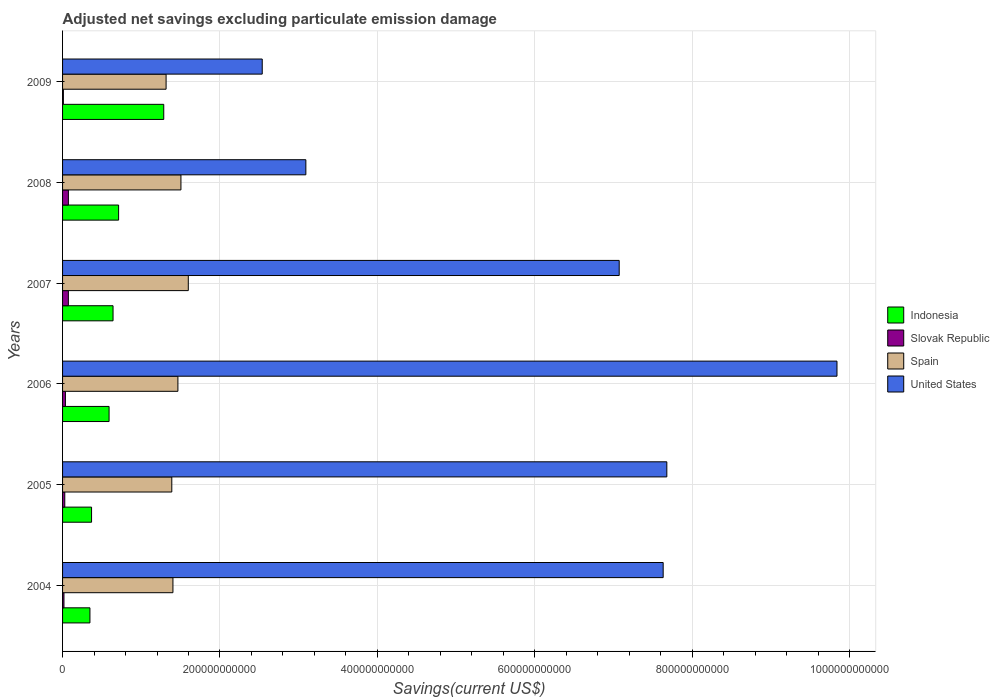Are the number of bars per tick equal to the number of legend labels?
Ensure brevity in your answer.  Yes. Are the number of bars on each tick of the Y-axis equal?
Your response must be concise. Yes. How many bars are there on the 4th tick from the top?
Keep it short and to the point. 4. How many bars are there on the 4th tick from the bottom?
Your response must be concise. 4. What is the label of the 3rd group of bars from the top?
Make the answer very short. 2007. What is the adjusted net savings in Spain in 2006?
Provide a short and direct response. 1.47e+11. Across all years, what is the maximum adjusted net savings in Slovak Republic?
Your answer should be compact. 7.40e+09. Across all years, what is the minimum adjusted net savings in Spain?
Your answer should be very brief. 1.32e+11. In which year was the adjusted net savings in United States maximum?
Your answer should be very brief. 2006. What is the total adjusted net savings in Spain in the graph?
Provide a short and direct response. 8.67e+11. What is the difference between the adjusted net savings in United States in 2005 and that in 2007?
Offer a terse response. 6.05e+1. What is the difference between the adjusted net savings in United States in 2004 and the adjusted net savings in Spain in 2008?
Provide a short and direct response. 6.13e+11. What is the average adjusted net savings in Indonesia per year?
Offer a very short reply. 6.58e+1. In the year 2007, what is the difference between the adjusted net savings in Spain and adjusted net savings in Indonesia?
Provide a short and direct response. 9.56e+1. In how many years, is the adjusted net savings in Indonesia greater than 720000000000 US$?
Your answer should be very brief. 0. What is the ratio of the adjusted net savings in United States in 2006 to that in 2007?
Ensure brevity in your answer.  1.39. Is the adjusted net savings in Slovak Republic in 2004 less than that in 2009?
Offer a very short reply. No. Is the difference between the adjusted net savings in Spain in 2004 and 2005 greater than the difference between the adjusted net savings in Indonesia in 2004 and 2005?
Offer a very short reply. Yes. What is the difference between the highest and the second highest adjusted net savings in Slovak Republic?
Your answer should be compact. 1.79e+07. What is the difference between the highest and the lowest adjusted net savings in Slovak Republic?
Your answer should be compact. 6.35e+09. In how many years, is the adjusted net savings in Indonesia greater than the average adjusted net savings in Indonesia taken over all years?
Your answer should be compact. 2. What does the 4th bar from the top in 2008 represents?
Your response must be concise. Indonesia. What does the 4th bar from the bottom in 2008 represents?
Make the answer very short. United States. Is it the case that in every year, the sum of the adjusted net savings in Slovak Republic and adjusted net savings in United States is greater than the adjusted net savings in Indonesia?
Provide a short and direct response. Yes. Are all the bars in the graph horizontal?
Make the answer very short. Yes. What is the difference between two consecutive major ticks on the X-axis?
Give a very brief answer. 2.00e+11. Are the values on the major ticks of X-axis written in scientific E-notation?
Ensure brevity in your answer.  No. Does the graph contain grids?
Ensure brevity in your answer.  Yes. How are the legend labels stacked?
Offer a terse response. Vertical. What is the title of the graph?
Offer a terse response. Adjusted net savings excluding particulate emission damage. What is the label or title of the X-axis?
Your answer should be very brief. Savings(current US$). What is the Savings(current US$) in Indonesia in 2004?
Provide a succinct answer. 3.48e+1. What is the Savings(current US$) of Slovak Republic in 2004?
Keep it short and to the point. 1.77e+09. What is the Savings(current US$) of Spain in 2004?
Make the answer very short. 1.40e+11. What is the Savings(current US$) of United States in 2004?
Your answer should be compact. 7.63e+11. What is the Savings(current US$) of Indonesia in 2005?
Your answer should be compact. 3.68e+1. What is the Savings(current US$) in Slovak Republic in 2005?
Offer a terse response. 2.82e+09. What is the Savings(current US$) in Spain in 2005?
Your answer should be very brief. 1.39e+11. What is the Savings(current US$) in United States in 2005?
Offer a very short reply. 7.68e+11. What is the Savings(current US$) of Indonesia in 2006?
Offer a terse response. 5.91e+1. What is the Savings(current US$) in Slovak Republic in 2006?
Offer a very short reply. 3.63e+09. What is the Savings(current US$) of Spain in 2006?
Provide a short and direct response. 1.47e+11. What is the Savings(current US$) of United States in 2006?
Provide a short and direct response. 9.84e+11. What is the Savings(current US$) of Indonesia in 2007?
Offer a very short reply. 6.41e+1. What is the Savings(current US$) in Slovak Republic in 2007?
Your response must be concise. 7.38e+09. What is the Savings(current US$) in Spain in 2007?
Offer a very short reply. 1.60e+11. What is the Savings(current US$) in United States in 2007?
Provide a succinct answer. 7.07e+11. What is the Savings(current US$) in Indonesia in 2008?
Your response must be concise. 7.12e+1. What is the Savings(current US$) in Slovak Republic in 2008?
Keep it short and to the point. 7.40e+09. What is the Savings(current US$) of Spain in 2008?
Your answer should be compact. 1.50e+11. What is the Savings(current US$) in United States in 2008?
Offer a terse response. 3.09e+11. What is the Savings(current US$) of Indonesia in 2009?
Your response must be concise. 1.29e+11. What is the Savings(current US$) of Slovak Republic in 2009?
Keep it short and to the point. 1.05e+09. What is the Savings(current US$) of Spain in 2009?
Provide a succinct answer. 1.32e+11. What is the Savings(current US$) of United States in 2009?
Give a very brief answer. 2.54e+11. Across all years, what is the maximum Savings(current US$) in Indonesia?
Provide a short and direct response. 1.29e+11. Across all years, what is the maximum Savings(current US$) in Slovak Republic?
Keep it short and to the point. 7.40e+09. Across all years, what is the maximum Savings(current US$) in Spain?
Offer a very short reply. 1.60e+11. Across all years, what is the maximum Savings(current US$) of United States?
Ensure brevity in your answer.  9.84e+11. Across all years, what is the minimum Savings(current US$) of Indonesia?
Provide a succinct answer. 3.48e+1. Across all years, what is the minimum Savings(current US$) in Slovak Republic?
Provide a short and direct response. 1.05e+09. Across all years, what is the minimum Savings(current US$) in Spain?
Your answer should be compact. 1.32e+11. Across all years, what is the minimum Savings(current US$) of United States?
Provide a succinct answer. 2.54e+11. What is the total Savings(current US$) of Indonesia in the graph?
Your answer should be compact. 3.95e+11. What is the total Savings(current US$) of Slovak Republic in the graph?
Your response must be concise. 2.41e+1. What is the total Savings(current US$) of Spain in the graph?
Your answer should be very brief. 8.67e+11. What is the total Savings(current US$) in United States in the graph?
Your answer should be very brief. 3.79e+12. What is the difference between the Savings(current US$) in Indonesia in 2004 and that in 2005?
Provide a short and direct response. -2.07e+09. What is the difference between the Savings(current US$) of Slovak Republic in 2004 and that in 2005?
Provide a short and direct response. -1.05e+09. What is the difference between the Savings(current US$) in Spain in 2004 and that in 2005?
Your answer should be very brief. 1.45e+09. What is the difference between the Savings(current US$) of United States in 2004 and that in 2005?
Provide a short and direct response. -4.65e+09. What is the difference between the Savings(current US$) in Indonesia in 2004 and that in 2006?
Provide a short and direct response. -2.43e+1. What is the difference between the Savings(current US$) in Slovak Republic in 2004 and that in 2006?
Provide a short and direct response. -1.85e+09. What is the difference between the Savings(current US$) of Spain in 2004 and that in 2006?
Offer a very short reply. -6.31e+09. What is the difference between the Savings(current US$) in United States in 2004 and that in 2006?
Your response must be concise. -2.21e+11. What is the difference between the Savings(current US$) of Indonesia in 2004 and that in 2007?
Your response must be concise. -2.94e+1. What is the difference between the Savings(current US$) of Slovak Republic in 2004 and that in 2007?
Keep it short and to the point. -5.61e+09. What is the difference between the Savings(current US$) in Spain in 2004 and that in 2007?
Your response must be concise. -1.95e+1. What is the difference between the Savings(current US$) of United States in 2004 and that in 2007?
Your answer should be compact. 5.59e+1. What is the difference between the Savings(current US$) in Indonesia in 2004 and that in 2008?
Your response must be concise. -3.64e+1. What is the difference between the Savings(current US$) in Slovak Republic in 2004 and that in 2008?
Provide a short and direct response. -5.62e+09. What is the difference between the Savings(current US$) in Spain in 2004 and that in 2008?
Provide a succinct answer. -1.02e+1. What is the difference between the Savings(current US$) in United States in 2004 and that in 2008?
Ensure brevity in your answer.  4.54e+11. What is the difference between the Savings(current US$) of Indonesia in 2004 and that in 2009?
Provide a succinct answer. -9.38e+1. What is the difference between the Savings(current US$) in Slovak Republic in 2004 and that in 2009?
Keep it short and to the point. 7.22e+08. What is the difference between the Savings(current US$) of Spain in 2004 and that in 2009?
Make the answer very short. 8.71e+09. What is the difference between the Savings(current US$) of United States in 2004 and that in 2009?
Provide a succinct answer. 5.09e+11. What is the difference between the Savings(current US$) in Indonesia in 2005 and that in 2006?
Keep it short and to the point. -2.22e+1. What is the difference between the Savings(current US$) in Slovak Republic in 2005 and that in 2006?
Offer a very short reply. -8.02e+08. What is the difference between the Savings(current US$) in Spain in 2005 and that in 2006?
Offer a very short reply. -7.76e+09. What is the difference between the Savings(current US$) of United States in 2005 and that in 2006?
Keep it short and to the point. -2.16e+11. What is the difference between the Savings(current US$) of Indonesia in 2005 and that in 2007?
Your answer should be very brief. -2.73e+1. What is the difference between the Savings(current US$) in Slovak Republic in 2005 and that in 2007?
Ensure brevity in your answer.  -4.56e+09. What is the difference between the Savings(current US$) in Spain in 2005 and that in 2007?
Your answer should be compact. -2.10e+1. What is the difference between the Savings(current US$) of United States in 2005 and that in 2007?
Ensure brevity in your answer.  6.05e+1. What is the difference between the Savings(current US$) in Indonesia in 2005 and that in 2008?
Your response must be concise. -3.44e+1. What is the difference between the Savings(current US$) of Slovak Republic in 2005 and that in 2008?
Make the answer very short. -4.57e+09. What is the difference between the Savings(current US$) of Spain in 2005 and that in 2008?
Offer a terse response. -1.16e+1. What is the difference between the Savings(current US$) of United States in 2005 and that in 2008?
Provide a short and direct response. 4.59e+11. What is the difference between the Savings(current US$) of Indonesia in 2005 and that in 2009?
Make the answer very short. -9.17e+1. What is the difference between the Savings(current US$) in Slovak Republic in 2005 and that in 2009?
Offer a terse response. 1.77e+09. What is the difference between the Savings(current US$) in Spain in 2005 and that in 2009?
Your answer should be compact. 7.26e+09. What is the difference between the Savings(current US$) of United States in 2005 and that in 2009?
Ensure brevity in your answer.  5.14e+11. What is the difference between the Savings(current US$) of Indonesia in 2006 and that in 2007?
Your response must be concise. -5.05e+09. What is the difference between the Savings(current US$) of Slovak Republic in 2006 and that in 2007?
Your answer should be compact. -3.75e+09. What is the difference between the Savings(current US$) of Spain in 2006 and that in 2007?
Make the answer very short. -1.32e+1. What is the difference between the Savings(current US$) of United States in 2006 and that in 2007?
Ensure brevity in your answer.  2.77e+11. What is the difference between the Savings(current US$) of Indonesia in 2006 and that in 2008?
Offer a terse response. -1.21e+1. What is the difference between the Savings(current US$) of Slovak Republic in 2006 and that in 2008?
Offer a very short reply. -3.77e+09. What is the difference between the Savings(current US$) of Spain in 2006 and that in 2008?
Keep it short and to the point. -3.86e+09. What is the difference between the Savings(current US$) in United States in 2006 and that in 2008?
Your response must be concise. 6.75e+11. What is the difference between the Savings(current US$) in Indonesia in 2006 and that in 2009?
Give a very brief answer. -6.95e+1. What is the difference between the Savings(current US$) of Slovak Republic in 2006 and that in 2009?
Ensure brevity in your answer.  2.57e+09. What is the difference between the Savings(current US$) of Spain in 2006 and that in 2009?
Offer a very short reply. 1.50e+1. What is the difference between the Savings(current US$) of United States in 2006 and that in 2009?
Make the answer very short. 7.30e+11. What is the difference between the Savings(current US$) in Indonesia in 2007 and that in 2008?
Keep it short and to the point. -7.06e+09. What is the difference between the Savings(current US$) in Slovak Republic in 2007 and that in 2008?
Offer a terse response. -1.79e+07. What is the difference between the Savings(current US$) in Spain in 2007 and that in 2008?
Offer a very short reply. 9.34e+09. What is the difference between the Savings(current US$) of United States in 2007 and that in 2008?
Provide a short and direct response. 3.98e+11. What is the difference between the Savings(current US$) of Indonesia in 2007 and that in 2009?
Offer a very short reply. -6.44e+1. What is the difference between the Savings(current US$) in Slovak Republic in 2007 and that in 2009?
Your answer should be compact. 6.33e+09. What is the difference between the Savings(current US$) in Spain in 2007 and that in 2009?
Your answer should be compact. 2.82e+1. What is the difference between the Savings(current US$) of United States in 2007 and that in 2009?
Offer a very short reply. 4.54e+11. What is the difference between the Savings(current US$) of Indonesia in 2008 and that in 2009?
Provide a succinct answer. -5.74e+1. What is the difference between the Savings(current US$) of Slovak Republic in 2008 and that in 2009?
Provide a succinct answer. 6.35e+09. What is the difference between the Savings(current US$) of Spain in 2008 and that in 2009?
Your answer should be very brief. 1.89e+1. What is the difference between the Savings(current US$) of United States in 2008 and that in 2009?
Offer a very short reply. 5.54e+1. What is the difference between the Savings(current US$) of Indonesia in 2004 and the Savings(current US$) of Slovak Republic in 2005?
Offer a terse response. 3.19e+1. What is the difference between the Savings(current US$) of Indonesia in 2004 and the Savings(current US$) of Spain in 2005?
Your response must be concise. -1.04e+11. What is the difference between the Savings(current US$) of Indonesia in 2004 and the Savings(current US$) of United States in 2005?
Offer a terse response. -7.33e+11. What is the difference between the Savings(current US$) in Slovak Republic in 2004 and the Savings(current US$) in Spain in 2005?
Ensure brevity in your answer.  -1.37e+11. What is the difference between the Savings(current US$) in Slovak Republic in 2004 and the Savings(current US$) in United States in 2005?
Your response must be concise. -7.66e+11. What is the difference between the Savings(current US$) of Spain in 2004 and the Savings(current US$) of United States in 2005?
Your answer should be very brief. -6.28e+11. What is the difference between the Savings(current US$) in Indonesia in 2004 and the Savings(current US$) in Slovak Republic in 2006?
Your response must be concise. 3.11e+1. What is the difference between the Savings(current US$) of Indonesia in 2004 and the Savings(current US$) of Spain in 2006?
Provide a succinct answer. -1.12e+11. What is the difference between the Savings(current US$) in Indonesia in 2004 and the Savings(current US$) in United States in 2006?
Your answer should be very brief. -9.49e+11. What is the difference between the Savings(current US$) in Slovak Republic in 2004 and the Savings(current US$) in Spain in 2006?
Ensure brevity in your answer.  -1.45e+11. What is the difference between the Savings(current US$) of Slovak Republic in 2004 and the Savings(current US$) of United States in 2006?
Offer a very short reply. -9.82e+11. What is the difference between the Savings(current US$) of Spain in 2004 and the Savings(current US$) of United States in 2006?
Offer a very short reply. -8.44e+11. What is the difference between the Savings(current US$) in Indonesia in 2004 and the Savings(current US$) in Slovak Republic in 2007?
Make the answer very short. 2.74e+1. What is the difference between the Savings(current US$) of Indonesia in 2004 and the Savings(current US$) of Spain in 2007?
Provide a short and direct response. -1.25e+11. What is the difference between the Savings(current US$) in Indonesia in 2004 and the Savings(current US$) in United States in 2007?
Your answer should be compact. -6.73e+11. What is the difference between the Savings(current US$) of Slovak Republic in 2004 and the Savings(current US$) of Spain in 2007?
Make the answer very short. -1.58e+11. What is the difference between the Savings(current US$) of Slovak Republic in 2004 and the Savings(current US$) of United States in 2007?
Provide a short and direct response. -7.06e+11. What is the difference between the Savings(current US$) in Spain in 2004 and the Savings(current US$) in United States in 2007?
Ensure brevity in your answer.  -5.67e+11. What is the difference between the Savings(current US$) in Indonesia in 2004 and the Savings(current US$) in Slovak Republic in 2008?
Your answer should be compact. 2.74e+1. What is the difference between the Savings(current US$) in Indonesia in 2004 and the Savings(current US$) in Spain in 2008?
Ensure brevity in your answer.  -1.16e+11. What is the difference between the Savings(current US$) in Indonesia in 2004 and the Savings(current US$) in United States in 2008?
Your response must be concise. -2.74e+11. What is the difference between the Savings(current US$) of Slovak Republic in 2004 and the Savings(current US$) of Spain in 2008?
Provide a short and direct response. -1.49e+11. What is the difference between the Savings(current US$) in Slovak Republic in 2004 and the Savings(current US$) in United States in 2008?
Offer a very short reply. -3.07e+11. What is the difference between the Savings(current US$) in Spain in 2004 and the Savings(current US$) in United States in 2008?
Provide a short and direct response. -1.69e+11. What is the difference between the Savings(current US$) in Indonesia in 2004 and the Savings(current US$) in Slovak Republic in 2009?
Offer a very short reply. 3.37e+1. What is the difference between the Savings(current US$) of Indonesia in 2004 and the Savings(current US$) of Spain in 2009?
Keep it short and to the point. -9.68e+1. What is the difference between the Savings(current US$) in Indonesia in 2004 and the Savings(current US$) in United States in 2009?
Provide a short and direct response. -2.19e+11. What is the difference between the Savings(current US$) in Slovak Republic in 2004 and the Savings(current US$) in Spain in 2009?
Give a very brief answer. -1.30e+11. What is the difference between the Savings(current US$) in Slovak Republic in 2004 and the Savings(current US$) in United States in 2009?
Offer a terse response. -2.52e+11. What is the difference between the Savings(current US$) in Spain in 2004 and the Savings(current US$) in United States in 2009?
Provide a short and direct response. -1.13e+11. What is the difference between the Savings(current US$) in Indonesia in 2005 and the Savings(current US$) in Slovak Republic in 2006?
Keep it short and to the point. 3.32e+1. What is the difference between the Savings(current US$) in Indonesia in 2005 and the Savings(current US$) in Spain in 2006?
Provide a succinct answer. -1.10e+11. What is the difference between the Savings(current US$) in Indonesia in 2005 and the Savings(current US$) in United States in 2006?
Make the answer very short. -9.47e+11. What is the difference between the Savings(current US$) in Slovak Republic in 2005 and the Savings(current US$) in Spain in 2006?
Make the answer very short. -1.44e+11. What is the difference between the Savings(current US$) in Slovak Republic in 2005 and the Savings(current US$) in United States in 2006?
Your response must be concise. -9.81e+11. What is the difference between the Savings(current US$) of Spain in 2005 and the Savings(current US$) of United States in 2006?
Keep it short and to the point. -8.45e+11. What is the difference between the Savings(current US$) in Indonesia in 2005 and the Savings(current US$) in Slovak Republic in 2007?
Provide a succinct answer. 2.95e+1. What is the difference between the Savings(current US$) in Indonesia in 2005 and the Savings(current US$) in Spain in 2007?
Your response must be concise. -1.23e+11. What is the difference between the Savings(current US$) in Indonesia in 2005 and the Savings(current US$) in United States in 2007?
Your answer should be compact. -6.70e+11. What is the difference between the Savings(current US$) in Slovak Republic in 2005 and the Savings(current US$) in Spain in 2007?
Keep it short and to the point. -1.57e+11. What is the difference between the Savings(current US$) of Slovak Republic in 2005 and the Savings(current US$) of United States in 2007?
Make the answer very short. -7.04e+11. What is the difference between the Savings(current US$) in Spain in 2005 and the Savings(current US$) in United States in 2007?
Provide a succinct answer. -5.69e+11. What is the difference between the Savings(current US$) in Indonesia in 2005 and the Savings(current US$) in Slovak Republic in 2008?
Your answer should be compact. 2.94e+1. What is the difference between the Savings(current US$) in Indonesia in 2005 and the Savings(current US$) in Spain in 2008?
Make the answer very short. -1.14e+11. What is the difference between the Savings(current US$) of Indonesia in 2005 and the Savings(current US$) of United States in 2008?
Offer a very short reply. -2.72e+11. What is the difference between the Savings(current US$) in Slovak Republic in 2005 and the Savings(current US$) in Spain in 2008?
Keep it short and to the point. -1.48e+11. What is the difference between the Savings(current US$) of Slovak Republic in 2005 and the Savings(current US$) of United States in 2008?
Provide a short and direct response. -3.06e+11. What is the difference between the Savings(current US$) in Spain in 2005 and the Savings(current US$) in United States in 2008?
Your answer should be very brief. -1.70e+11. What is the difference between the Savings(current US$) in Indonesia in 2005 and the Savings(current US$) in Slovak Republic in 2009?
Ensure brevity in your answer.  3.58e+1. What is the difference between the Savings(current US$) in Indonesia in 2005 and the Savings(current US$) in Spain in 2009?
Ensure brevity in your answer.  -9.47e+1. What is the difference between the Savings(current US$) in Indonesia in 2005 and the Savings(current US$) in United States in 2009?
Offer a terse response. -2.17e+11. What is the difference between the Savings(current US$) of Slovak Republic in 2005 and the Savings(current US$) of Spain in 2009?
Make the answer very short. -1.29e+11. What is the difference between the Savings(current US$) of Slovak Republic in 2005 and the Savings(current US$) of United States in 2009?
Offer a very short reply. -2.51e+11. What is the difference between the Savings(current US$) in Spain in 2005 and the Savings(current US$) in United States in 2009?
Give a very brief answer. -1.15e+11. What is the difference between the Savings(current US$) of Indonesia in 2006 and the Savings(current US$) of Slovak Republic in 2007?
Your answer should be very brief. 5.17e+1. What is the difference between the Savings(current US$) in Indonesia in 2006 and the Savings(current US$) in Spain in 2007?
Make the answer very short. -1.01e+11. What is the difference between the Savings(current US$) of Indonesia in 2006 and the Savings(current US$) of United States in 2007?
Provide a short and direct response. -6.48e+11. What is the difference between the Savings(current US$) of Slovak Republic in 2006 and the Savings(current US$) of Spain in 2007?
Your answer should be very brief. -1.56e+11. What is the difference between the Savings(current US$) of Slovak Republic in 2006 and the Savings(current US$) of United States in 2007?
Your answer should be compact. -7.04e+11. What is the difference between the Savings(current US$) of Spain in 2006 and the Savings(current US$) of United States in 2007?
Offer a terse response. -5.61e+11. What is the difference between the Savings(current US$) of Indonesia in 2006 and the Savings(current US$) of Slovak Republic in 2008?
Your response must be concise. 5.17e+1. What is the difference between the Savings(current US$) in Indonesia in 2006 and the Savings(current US$) in Spain in 2008?
Your answer should be very brief. -9.13e+1. What is the difference between the Savings(current US$) of Indonesia in 2006 and the Savings(current US$) of United States in 2008?
Offer a terse response. -2.50e+11. What is the difference between the Savings(current US$) of Slovak Republic in 2006 and the Savings(current US$) of Spain in 2008?
Your answer should be compact. -1.47e+11. What is the difference between the Savings(current US$) in Slovak Republic in 2006 and the Savings(current US$) in United States in 2008?
Make the answer very short. -3.06e+11. What is the difference between the Savings(current US$) in Spain in 2006 and the Savings(current US$) in United States in 2008?
Your response must be concise. -1.63e+11. What is the difference between the Savings(current US$) of Indonesia in 2006 and the Savings(current US$) of Slovak Republic in 2009?
Keep it short and to the point. 5.80e+1. What is the difference between the Savings(current US$) of Indonesia in 2006 and the Savings(current US$) of Spain in 2009?
Make the answer very short. -7.24e+1. What is the difference between the Savings(current US$) in Indonesia in 2006 and the Savings(current US$) in United States in 2009?
Offer a terse response. -1.95e+11. What is the difference between the Savings(current US$) in Slovak Republic in 2006 and the Savings(current US$) in Spain in 2009?
Provide a short and direct response. -1.28e+11. What is the difference between the Savings(current US$) in Slovak Republic in 2006 and the Savings(current US$) in United States in 2009?
Offer a terse response. -2.50e+11. What is the difference between the Savings(current US$) of Spain in 2006 and the Savings(current US$) of United States in 2009?
Make the answer very short. -1.07e+11. What is the difference between the Savings(current US$) in Indonesia in 2007 and the Savings(current US$) in Slovak Republic in 2008?
Provide a short and direct response. 5.67e+1. What is the difference between the Savings(current US$) in Indonesia in 2007 and the Savings(current US$) in Spain in 2008?
Provide a succinct answer. -8.63e+1. What is the difference between the Savings(current US$) in Indonesia in 2007 and the Savings(current US$) in United States in 2008?
Your answer should be very brief. -2.45e+11. What is the difference between the Savings(current US$) in Slovak Republic in 2007 and the Savings(current US$) in Spain in 2008?
Make the answer very short. -1.43e+11. What is the difference between the Savings(current US$) in Slovak Republic in 2007 and the Savings(current US$) in United States in 2008?
Your answer should be compact. -3.02e+11. What is the difference between the Savings(current US$) in Spain in 2007 and the Savings(current US$) in United States in 2008?
Offer a very short reply. -1.49e+11. What is the difference between the Savings(current US$) in Indonesia in 2007 and the Savings(current US$) in Slovak Republic in 2009?
Provide a short and direct response. 6.31e+1. What is the difference between the Savings(current US$) in Indonesia in 2007 and the Savings(current US$) in Spain in 2009?
Ensure brevity in your answer.  -6.74e+1. What is the difference between the Savings(current US$) of Indonesia in 2007 and the Savings(current US$) of United States in 2009?
Your answer should be very brief. -1.90e+11. What is the difference between the Savings(current US$) of Slovak Republic in 2007 and the Savings(current US$) of Spain in 2009?
Keep it short and to the point. -1.24e+11. What is the difference between the Savings(current US$) in Slovak Republic in 2007 and the Savings(current US$) in United States in 2009?
Provide a succinct answer. -2.46e+11. What is the difference between the Savings(current US$) of Spain in 2007 and the Savings(current US$) of United States in 2009?
Offer a terse response. -9.40e+1. What is the difference between the Savings(current US$) of Indonesia in 2008 and the Savings(current US$) of Slovak Republic in 2009?
Your answer should be compact. 7.02e+1. What is the difference between the Savings(current US$) of Indonesia in 2008 and the Savings(current US$) of Spain in 2009?
Make the answer very short. -6.03e+1. What is the difference between the Savings(current US$) in Indonesia in 2008 and the Savings(current US$) in United States in 2009?
Your answer should be compact. -1.83e+11. What is the difference between the Savings(current US$) in Slovak Republic in 2008 and the Savings(current US$) in Spain in 2009?
Provide a succinct answer. -1.24e+11. What is the difference between the Savings(current US$) in Slovak Republic in 2008 and the Savings(current US$) in United States in 2009?
Make the answer very short. -2.46e+11. What is the difference between the Savings(current US$) of Spain in 2008 and the Savings(current US$) of United States in 2009?
Offer a very short reply. -1.03e+11. What is the average Savings(current US$) in Indonesia per year?
Your answer should be compact. 6.58e+1. What is the average Savings(current US$) in Slovak Republic per year?
Keep it short and to the point. 4.01e+09. What is the average Savings(current US$) of Spain per year?
Your answer should be very brief. 1.45e+11. What is the average Savings(current US$) of United States per year?
Make the answer very short. 6.31e+11. In the year 2004, what is the difference between the Savings(current US$) of Indonesia and Savings(current US$) of Slovak Republic?
Give a very brief answer. 3.30e+1. In the year 2004, what is the difference between the Savings(current US$) in Indonesia and Savings(current US$) in Spain?
Provide a short and direct response. -1.05e+11. In the year 2004, what is the difference between the Savings(current US$) of Indonesia and Savings(current US$) of United States?
Offer a very short reply. -7.28e+11. In the year 2004, what is the difference between the Savings(current US$) of Slovak Republic and Savings(current US$) of Spain?
Offer a terse response. -1.38e+11. In the year 2004, what is the difference between the Savings(current US$) of Slovak Republic and Savings(current US$) of United States?
Your answer should be compact. -7.61e+11. In the year 2004, what is the difference between the Savings(current US$) in Spain and Savings(current US$) in United States?
Make the answer very short. -6.23e+11. In the year 2005, what is the difference between the Savings(current US$) of Indonesia and Savings(current US$) of Slovak Republic?
Give a very brief answer. 3.40e+1. In the year 2005, what is the difference between the Savings(current US$) of Indonesia and Savings(current US$) of Spain?
Your answer should be compact. -1.02e+11. In the year 2005, what is the difference between the Savings(current US$) of Indonesia and Savings(current US$) of United States?
Offer a very short reply. -7.31e+11. In the year 2005, what is the difference between the Savings(current US$) of Slovak Republic and Savings(current US$) of Spain?
Your answer should be compact. -1.36e+11. In the year 2005, what is the difference between the Savings(current US$) of Slovak Republic and Savings(current US$) of United States?
Your response must be concise. -7.65e+11. In the year 2005, what is the difference between the Savings(current US$) in Spain and Savings(current US$) in United States?
Your answer should be very brief. -6.29e+11. In the year 2006, what is the difference between the Savings(current US$) of Indonesia and Savings(current US$) of Slovak Republic?
Ensure brevity in your answer.  5.55e+1. In the year 2006, what is the difference between the Savings(current US$) in Indonesia and Savings(current US$) in Spain?
Offer a terse response. -8.75e+1. In the year 2006, what is the difference between the Savings(current US$) in Indonesia and Savings(current US$) in United States?
Ensure brevity in your answer.  -9.25e+11. In the year 2006, what is the difference between the Savings(current US$) in Slovak Republic and Savings(current US$) in Spain?
Ensure brevity in your answer.  -1.43e+11. In the year 2006, what is the difference between the Savings(current US$) of Slovak Republic and Savings(current US$) of United States?
Keep it short and to the point. -9.80e+11. In the year 2006, what is the difference between the Savings(current US$) in Spain and Savings(current US$) in United States?
Your answer should be compact. -8.37e+11. In the year 2007, what is the difference between the Savings(current US$) of Indonesia and Savings(current US$) of Slovak Republic?
Ensure brevity in your answer.  5.68e+1. In the year 2007, what is the difference between the Savings(current US$) in Indonesia and Savings(current US$) in Spain?
Offer a very short reply. -9.56e+1. In the year 2007, what is the difference between the Savings(current US$) in Indonesia and Savings(current US$) in United States?
Provide a succinct answer. -6.43e+11. In the year 2007, what is the difference between the Savings(current US$) in Slovak Republic and Savings(current US$) in Spain?
Offer a terse response. -1.52e+11. In the year 2007, what is the difference between the Savings(current US$) of Slovak Republic and Savings(current US$) of United States?
Offer a very short reply. -7.00e+11. In the year 2007, what is the difference between the Savings(current US$) in Spain and Savings(current US$) in United States?
Offer a terse response. -5.48e+11. In the year 2008, what is the difference between the Savings(current US$) in Indonesia and Savings(current US$) in Slovak Republic?
Provide a succinct answer. 6.38e+1. In the year 2008, what is the difference between the Savings(current US$) of Indonesia and Savings(current US$) of Spain?
Your answer should be very brief. -7.92e+1. In the year 2008, what is the difference between the Savings(current US$) in Indonesia and Savings(current US$) in United States?
Your answer should be compact. -2.38e+11. In the year 2008, what is the difference between the Savings(current US$) of Slovak Republic and Savings(current US$) of Spain?
Provide a short and direct response. -1.43e+11. In the year 2008, what is the difference between the Savings(current US$) in Slovak Republic and Savings(current US$) in United States?
Ensure brevity in your answer.  -3.02e+11. In the year 2008, what is the difference between the Savings(current US$) of Spain and Savings(current US$) of United States?
Ensure brevity in your answer.  -1.59e+11. In the year 2009, what is the difference between the Savings(current US$) in Indonesia and Savings(current US$) in Slovak Republic?
Make the answer very short. 1.28e+11. In the year 2009, what is the difference between the Savings(current US$) in Indonesia and Savings(current US$) in Spain?
Give a very brief answer. -2.97e+09. In the year 2009, what is the difference between the Savings(current US$) of Indonesia and Savings(current US$) of United States?
Provide a short and direct response. -1.25e+11. In the year 2009, what is the difference between the Savings(current US$) of Slovak Republic and Savings(current US$) of Spain?
Provide a short and direct response. -1.30e+11. In the year 2009, what is the difference between the Savings(current US$) of Slovak Republic and Savings(current US$) of United States?
Provide a short and direct response. -2.53e+11. In the year 2009, what is the difference between the Savings(current US$) in Spain and Savings(current US$) in United States?
Give a very brief answer. -1.22e+11. What is the ratio of the Savings(current US$) in Indonesia in 2004 to that in 2005?
Keep it short and to the point. 0.94. What is the ratio of the Savings(current US$) of Slovak Republic in 2004 to that in 2005?
Give a very brief answer. 0.63. What is the ratio of the Savings(current US$) of Spain in 2004 to that in 2005?
Offer a terse response. 1.01. What is the ratio of the Savings(current US$) in Indonesia in 2004 to that in 2006?
Offer a very short reply. 0.59. What is the ratio of the Savings(current US$) in Slovak Republic in 2004 to that in 2006?
Your response must be concise. 0.49. What is the ratio of the Savings(current US$) in United States in 2004 to that in 2006?
Keep it short and to the point. 0.78. What is the ratio of the Savings(current US$) in Indonesia in 2004 to that in 2007?
Offer a very short reply. 0.54. What is the ratio of the Savings(current US$) of Slovak Republic in 2004 to that in 2007?
Give a very brief answer. 0.24. What is the ratio of the Savings(current US$) in Spain in 2004 to that in 2007?
Your answer should be compact. 0.88. What is the ratio of the Savings(current US$) of United States in 2004 to that in 2007?
Provide a short and direct response. 1.08. What is the ratio of the Savings(current US$) in Indonesia in 2004 to that in 2008?
Your response must be concise. 0.49. What is the ratio of the Savings(current US$) of Slovak Republic in 2004 to that in 2008?
Offer a terse response. 0.24. What is the ratio of the Savings(current US$) of Spain in 2004 to that in 2008?
Offer a very short reply. 0.93. What is the ratio of the Savings(current US$) of United States in 2004 to that in 2008?
Keep it short and to the point. 2.47. What is the ratio of the Savings(current US$) of Indonesia in 2004 to that in 2009?
Make the answer very short. 0.27. What is the ratio of the Savings(current US$) in Slovak Republic in 2004 to that in 2009?
Your answer should be compact. 1.69. What is the ratio of the Savings(current US$) in Spain in 2004 to that in 2009?
Keep it short and to the point. 1.07. What is the ratio of the Savings(current US$) in United States in 2004 to that in 2009?
Your answer should be very brief. 3.01. What is the ratio of the Savings(current US$) of Indonesia in 2005 to that in 2006?
Provide a short and direct response. 0.62. What is the ratio of the Savings(current US$) in Slovak Republic in 2005 to that in 2006?
Ensure brevity in your answer.  0.78. What is the ratio of the Savings(current US$) of Spain in 2005 to that in 2006?
Provide a succinct answer. 0.95. What is the ratio of the Savings(current US$) in United States in 2005 to that in 2006?
Your answer should be compact. 0.78. What is the ratio of the Savings(current US$) in Indonesia in 2005 to that in 2007?
Your answer should be very brief. 0.57. What is the ratio of the Savings(current US$) in Slovak Republic in 2005 to that in 2007?
Provide a succinct answer. 0.38. What is the ratio of the Savings(current US$) of Spain in 2005 to that in 2007?
Provide a short and direct response. 0.87. What is the ratio of the Savings(current US$) in United States in 2005 to that in 2007?
Give a very brief answer. 1.09. What is the ratio of the Savings(current US$) of Indonesia in 2005 to that in 2008?
Your answer should be very brief. 0.52. What is the ratio of the Savings(current US$) of Slovak Republic in 2005 to that in 2008?
Give a very brief answer. 0.38. What is the ratio of the Savings(current US$) in Spain in 2005 to that in 2008?
Provide a short and direct response. 0.92. What is the ratio of the Savings(current US$) of United States in 2005 to that in 2008?
Provide a short and direct response. 2.48. What is the ratio of the Savings(current US$) of Indonesia in 2005 to that in 2009?
Provide a short and direct response. 0.29. What is the ratio of the Savings(current US$) of Slovak Republic in 2005 to that in 2009?
Give a very brief answer. 2.69. What is the ratio of the Savings(current US$) of Spain in 2005 to that in 2009?
Give a very brief answer. 1.06. What is the ratio of the Savings(current US$) of United States in 2005 to that in 2009?
Your response must be concise. 3.03. What is the ratio of the Savings(current US$) in Indonesia in 2006 to that in 2007?
Your answer should be compact. 0.92. What is the ratio of the Savings(current US$) of Slovak Republic in 2006 to that in 2007?
Ensure brevity in your answer.  0.49. What is the ratio of the Savings(current US$) in Spain in 2006 to that in 2007?
Provide a succinct answer. 0.92. What is the ratio of the Savings(current US$) in United States in 2006 to that in 2007?
Provide a succinct answer. 1.39. What is the ratio of the Savings(current US$) in Indonesia in 2006 to that in 2008?
Offer a very short reply. 0.83. What is the ratio of the Savings(current US$) in Slovak Republic in 2006 to that in 2008?
Your answer should be compact. 0.49. What is the ratio of the Savings(current US$) in Spain in 2006 to that in 2008?
Offer a very short reply. 0.97. What is the ratio of the Savings(current US$) in United States in 2006 to that in 2008?
Keep it short and to the point. 3.18. What is the ratio of the Savings(current US$) of Indonesia in 2006 to that in 2009?
Offer a terse response. 0.46. What is the ratio of the Savings(current US$) of Slovak Republic in 2006 to that in 2009?
Your response must be concise. 3.45. What is the ratio of the Savings(current US$) in Spain in 2006 to that in 2009?
Offer a terse response. 1.11. What is the ratio of the Savings(current US$) in United States in 2006 to that in 2009?
Give a very brief answer. 3.88. What is the ratio of the Savings(current US$) in Indonesia in 2007 to that in 2008?
Provide a succinct answer. 0.9. What is the ratio of the Savings(current US$) in Spain in 2007 to that in 2008?
Your response must be concise. 1.06. What is the ratio of the Savings(current US$) of United States in 2007 to that in 2008?
Give a very brief answer. 2.29. What is the ratio of the Savings(current US$) of Indonesia in 2007 to that in 2009?
Offer a very short reply. 0.5. What is the ratio of the Savings(current US$) in Slovak Republic in 2007 to that in 2009?
Offer a very short reply. 7.02. What is the ratio of the Savings(current US$) of Spain in 2007 to that in 2009?
Your answer should be very brief. 1.21. What is the ratio of the Savings(current US$) in United States in 2007 to that in 2009?
Provide a succinct answer. 2.79. What is the ratio of the Savings(current US$) of Indonesia in 2008 to that in 2009?
Keep it short and to the point. 0.55. What is the ratio of the Savings(current US$) in Slovak Republic in 2008 to that in 2009?
Ensure brevity in your answer.  7.03. What is the ratio of the Savings(current US$) in Spain in 2008 to that in 2009?
Keep it short and to the point. 1.14. What is the ratio of the Savings(current US$) of United States in 2008 to that in 2009?
Provide a short and direct response. 1.22. What is the difference between the highest and the second highest Savings(current US$) of Indonesia?
Give a very brief answer. 5.74e+1. What is the difference between the highest and the second highest Savings(current US$) in Slovak Republic?
Your response must be concise. 1.79e+07. What is the difference between the highest and the second highest Savings(current US$) in Spain?
Your response must be concise. 9.34e+09. What is the difference between the highest and the second highest Savings(current US$) in United States?
Offer a terse response. 2.16e+11. What is the difference between the highest and the lowest Savings(current US$) of Indonesia?
Your answer should be compact. 9.38e+1. What is the difference between the highest and the lowest Savings(current US$) in Slovak Republic?
Provide a succinct answer. 6.35e+09. What is the difference between the highest and the lowest Savings(current US$) of Spain?
Give a very brief answer. 2.82e+1. What is the difference between the highest and the lowest Savings(current US$) of United States?
Provide a succinct answer. 7.30e+11. 